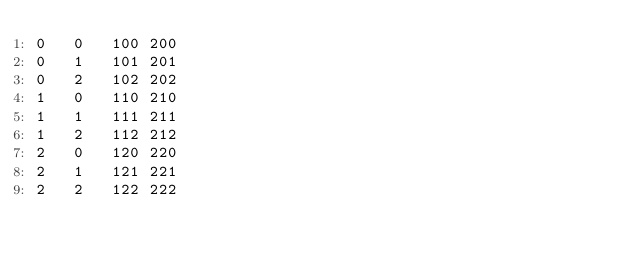<code> <loc_0><loc_0><loc_500><loc_500><_SQL_>0	0	100	200
0	1	101	201
0	2	102	202
1	0	110	210
1	1	111	211
1	2	112	212
2	0	120	220
2	1	121	221
2	2	122	222
</code> 